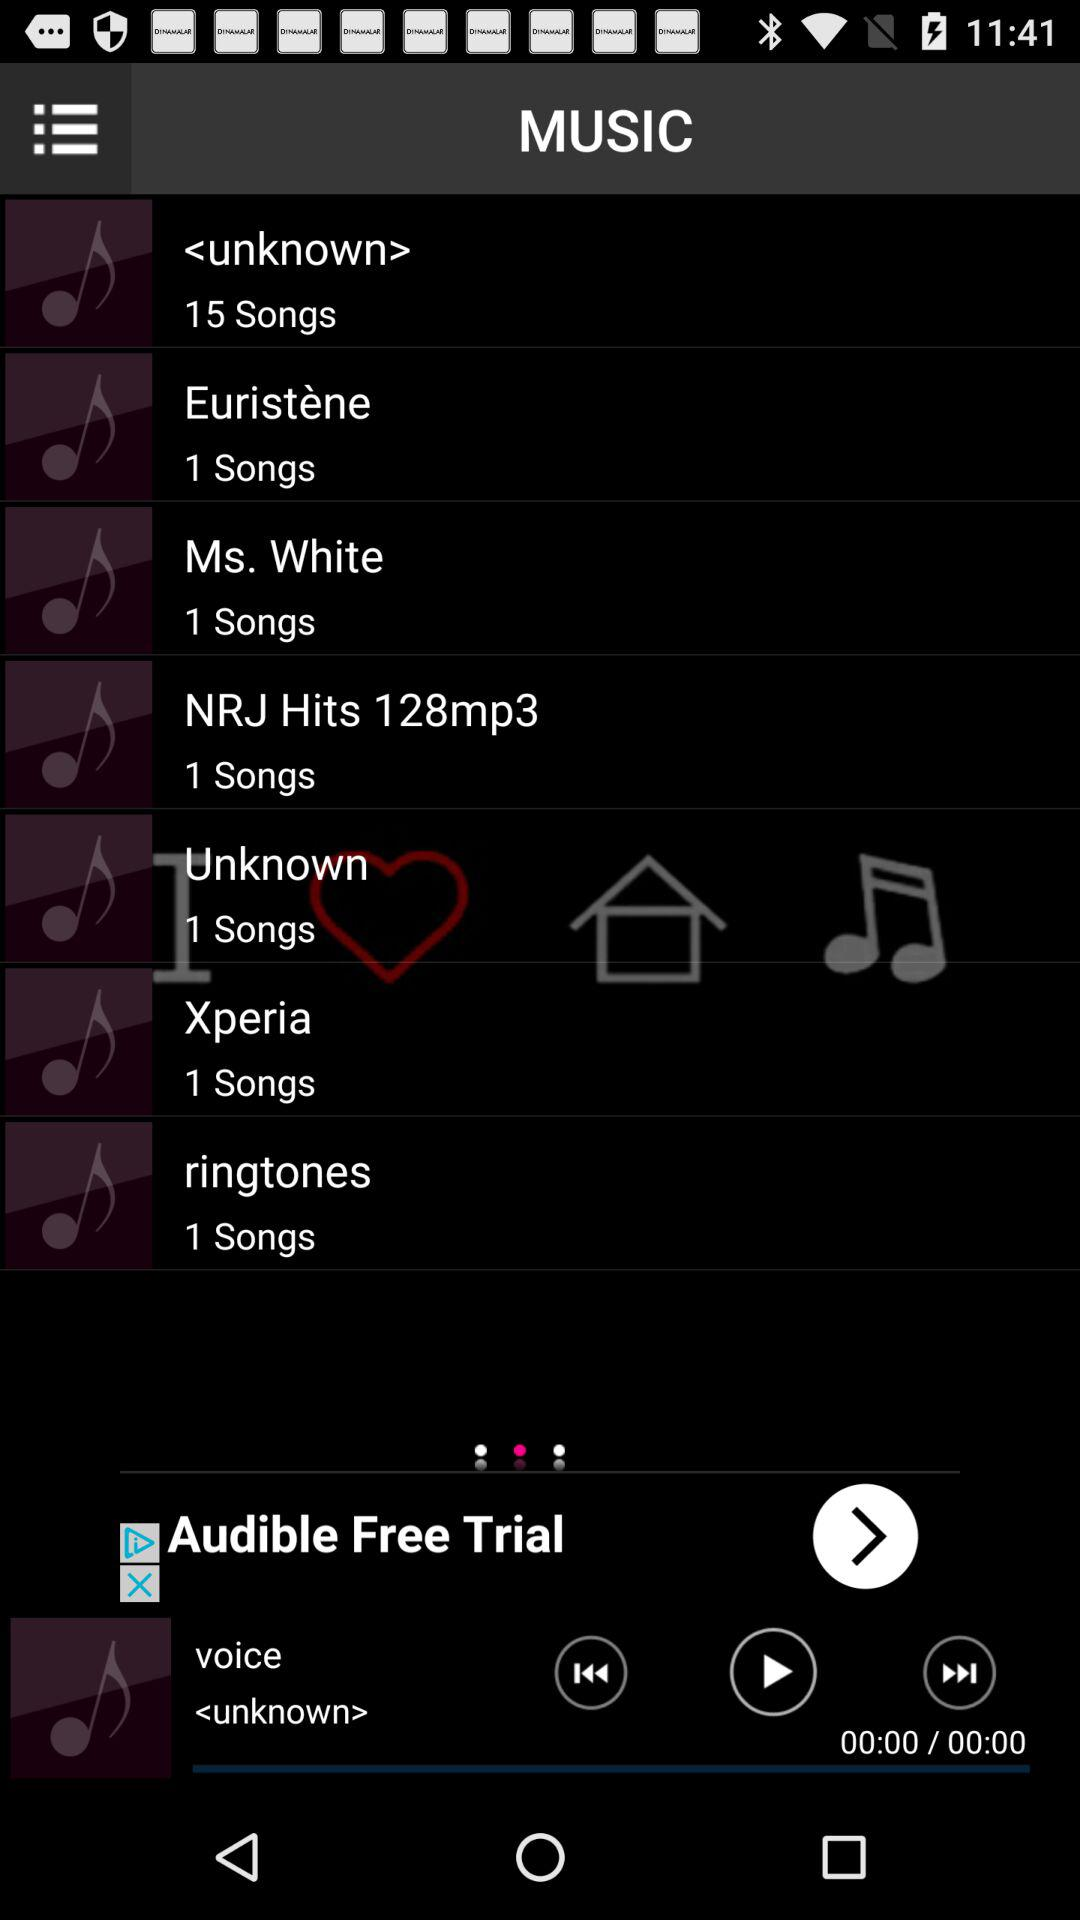What is the name of the last played song? The name of the last played song is "voice". 